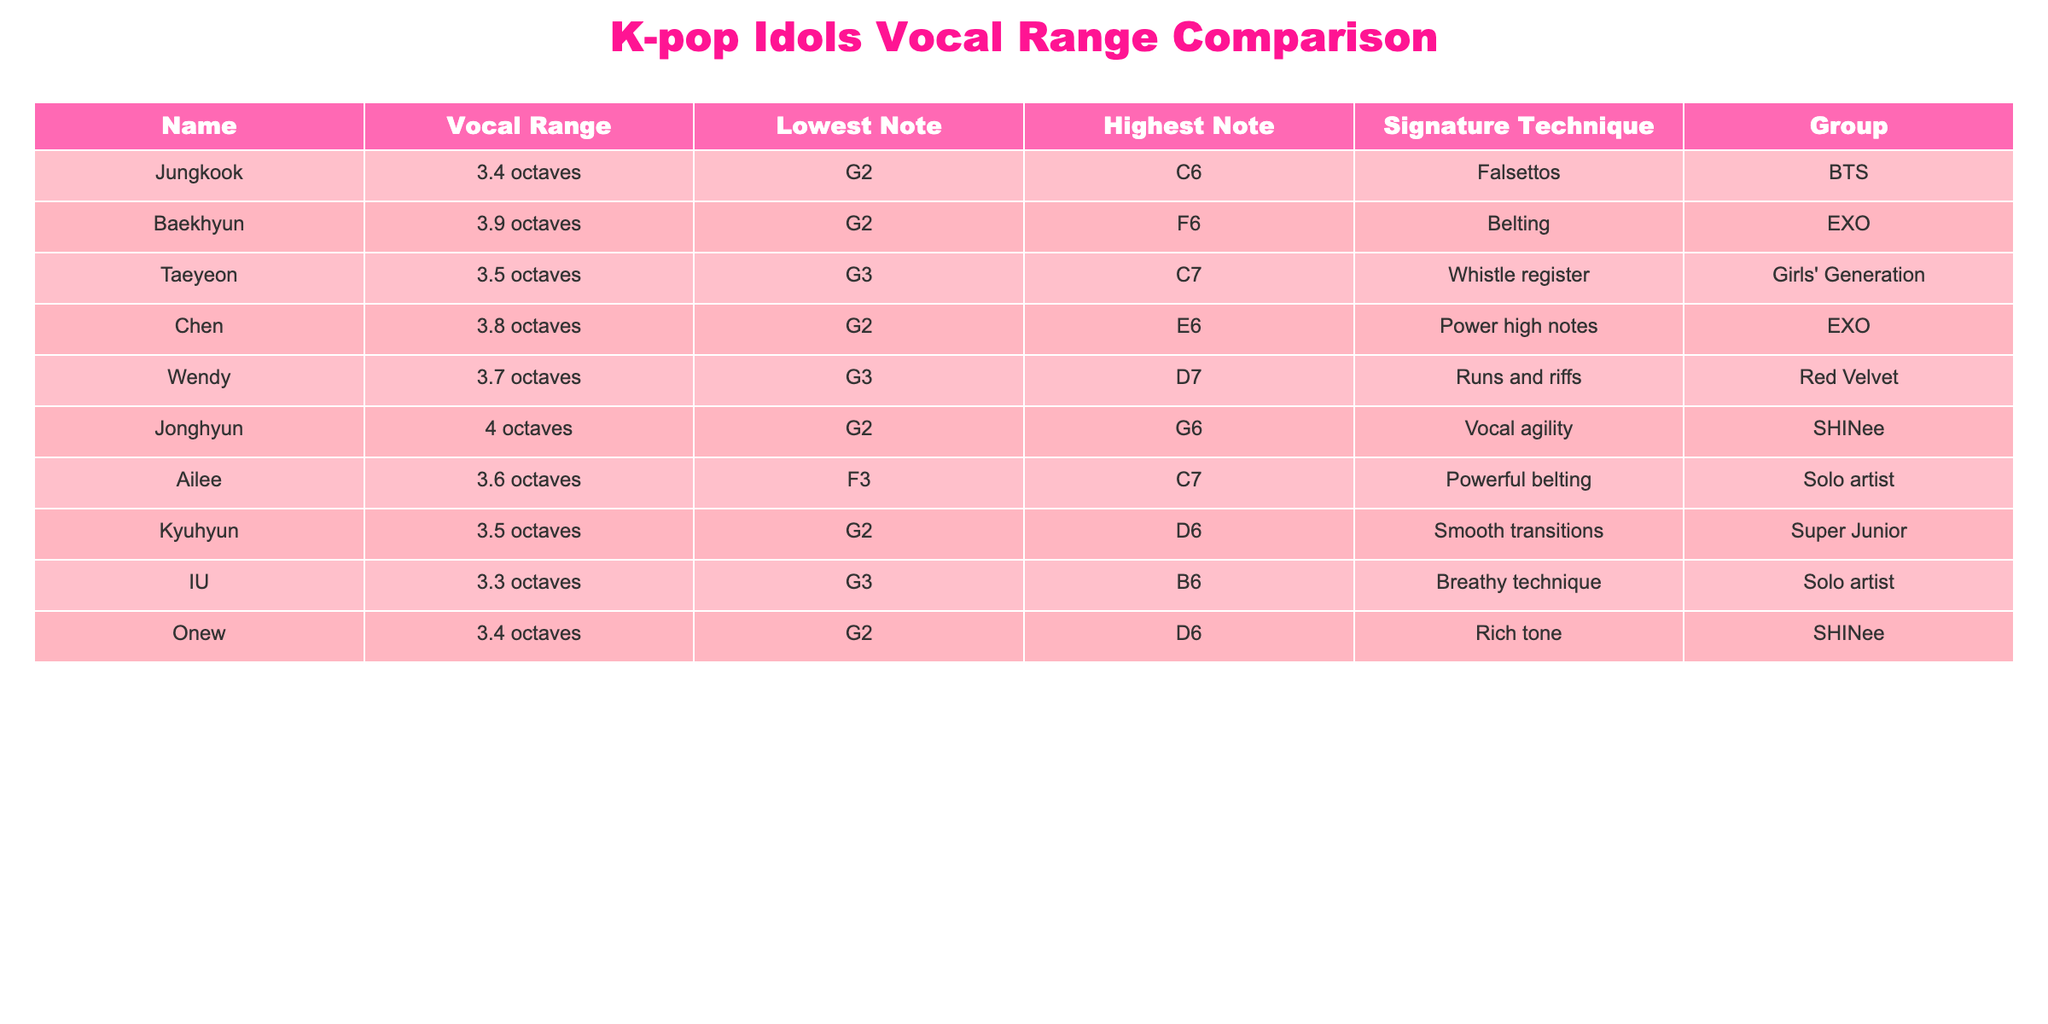What is the vocal range of Baekhyun? According to the table, Baekhyun has a vocal range of 3.9 octaves.
Answer: 3.9 octaves Who has the lowest note of G2 among the idols listed? In the table, both Jungkook and Baekhyun have the lowest note of G2.
Answer: Jungkook and Baekhyun What is the average vocal range of all the idols in the table? The vocal ranges are as follows: 3.4, 3.9, 3.5, 3.8, 3.7, 4.0, 3.6, 3.5, and 3.3 octaves. Adding them gives 30.7, and dividing by the 9 idols gives an average of approximately 3.41 octaves.
Answer: 3.41 octaves Is Wendy known for her belting technique? The table indicates that Wendy is known for runs and riffs, not belting.
Answer: No Which idol has the highest vocal range? Jonghyun has the highest vocal range at 4 octaves, as noted in the table.
Answer: 4 octaves What is the difference in vocal range between Chen and IU? Chen has a range of 3.8 octaves, and IU has 3.3 octaves. The difference is 0.5 octaves (3.8 - 3.3).
Answer: 0.5 octaves Which group has the most idols listed in the table? The table shows that EXO has two idols (Baekhyun and Chen), while the other groups have one each. Therefore, EXO has the most idols listed.
Answer: EXO Is Taeyeon's highest note higher than Wendy's highest note? Taeyeon's highest note is C7, whereas Wendy's highest is D7. Since D7 is higher than C7, the answer is no.
Answer: No Who has the highest note among the idols listed? The highest note in the table is D7, performed by Wendy, as shown in her row.
Answer: Wendy 